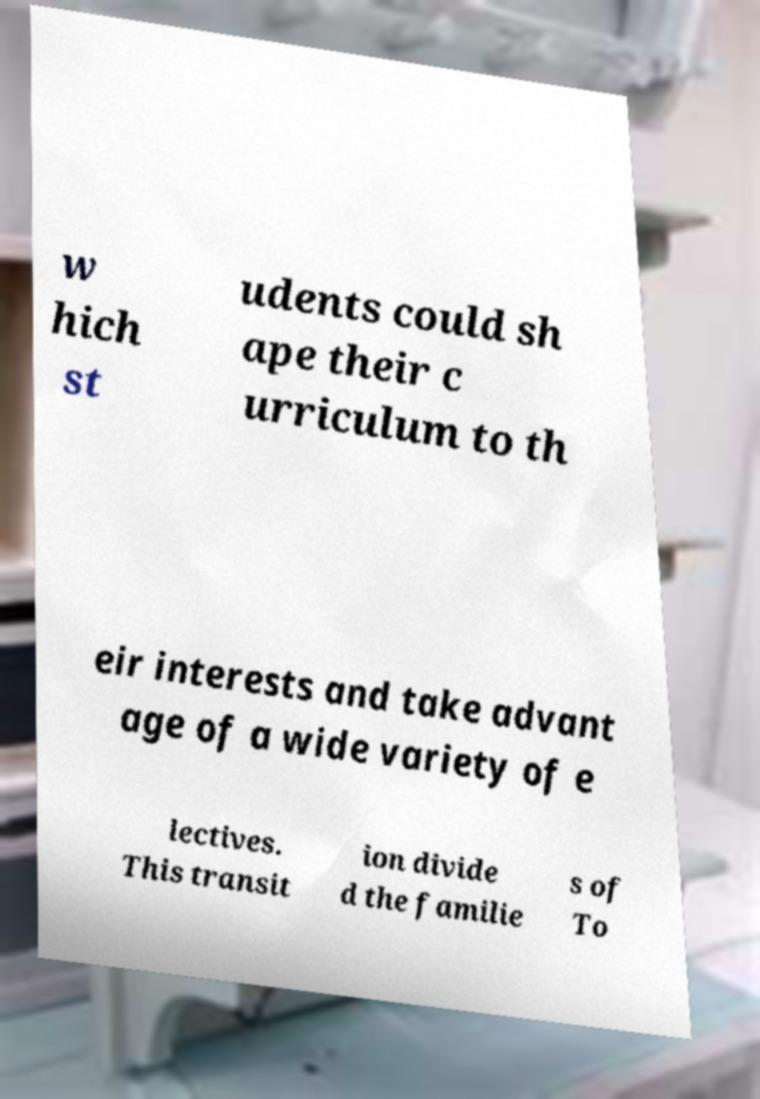There's text embedded in this image that I need extracted. Can you transcribe it verbatim? w hich st udents could sh ape their c urriculum to th eir interests and take advant age of a wide variety of e lectives. This transit ion divide d the familie s of To 